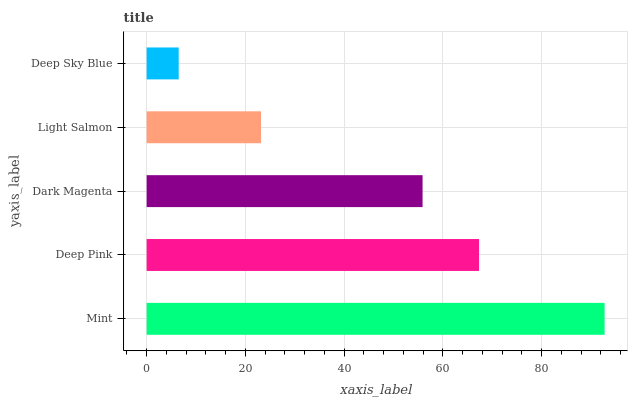Is Deep Sky Blue the minimum?
Answer yes or no. Yes. Is Mint the maximum?
Answer yes or no. Yes. Is Deep Pink the minimum?
Answer yes or no. No. Is Deep Pink the maximum?
Answer yes or no. No. Is Mint greater than Deep Pink?
Answer yes or no. Yes. Is Deep Pink less than Mint?
Answer yes or no. Yes. Is Deep Pink greater than Mint?
Answer yes or no. No. Is Mint less than Deep Pink?
Answer yes or no. No. Is Dark Magenta the high median?
Answer yes or no. Yes. Is Dark Magenta the low median?
Answer yes or no. Yes. Is Light Salmon the high median?
Answer yes or no. No. Is Deep Sky Blue the low median?
Answer yes or no. No. 